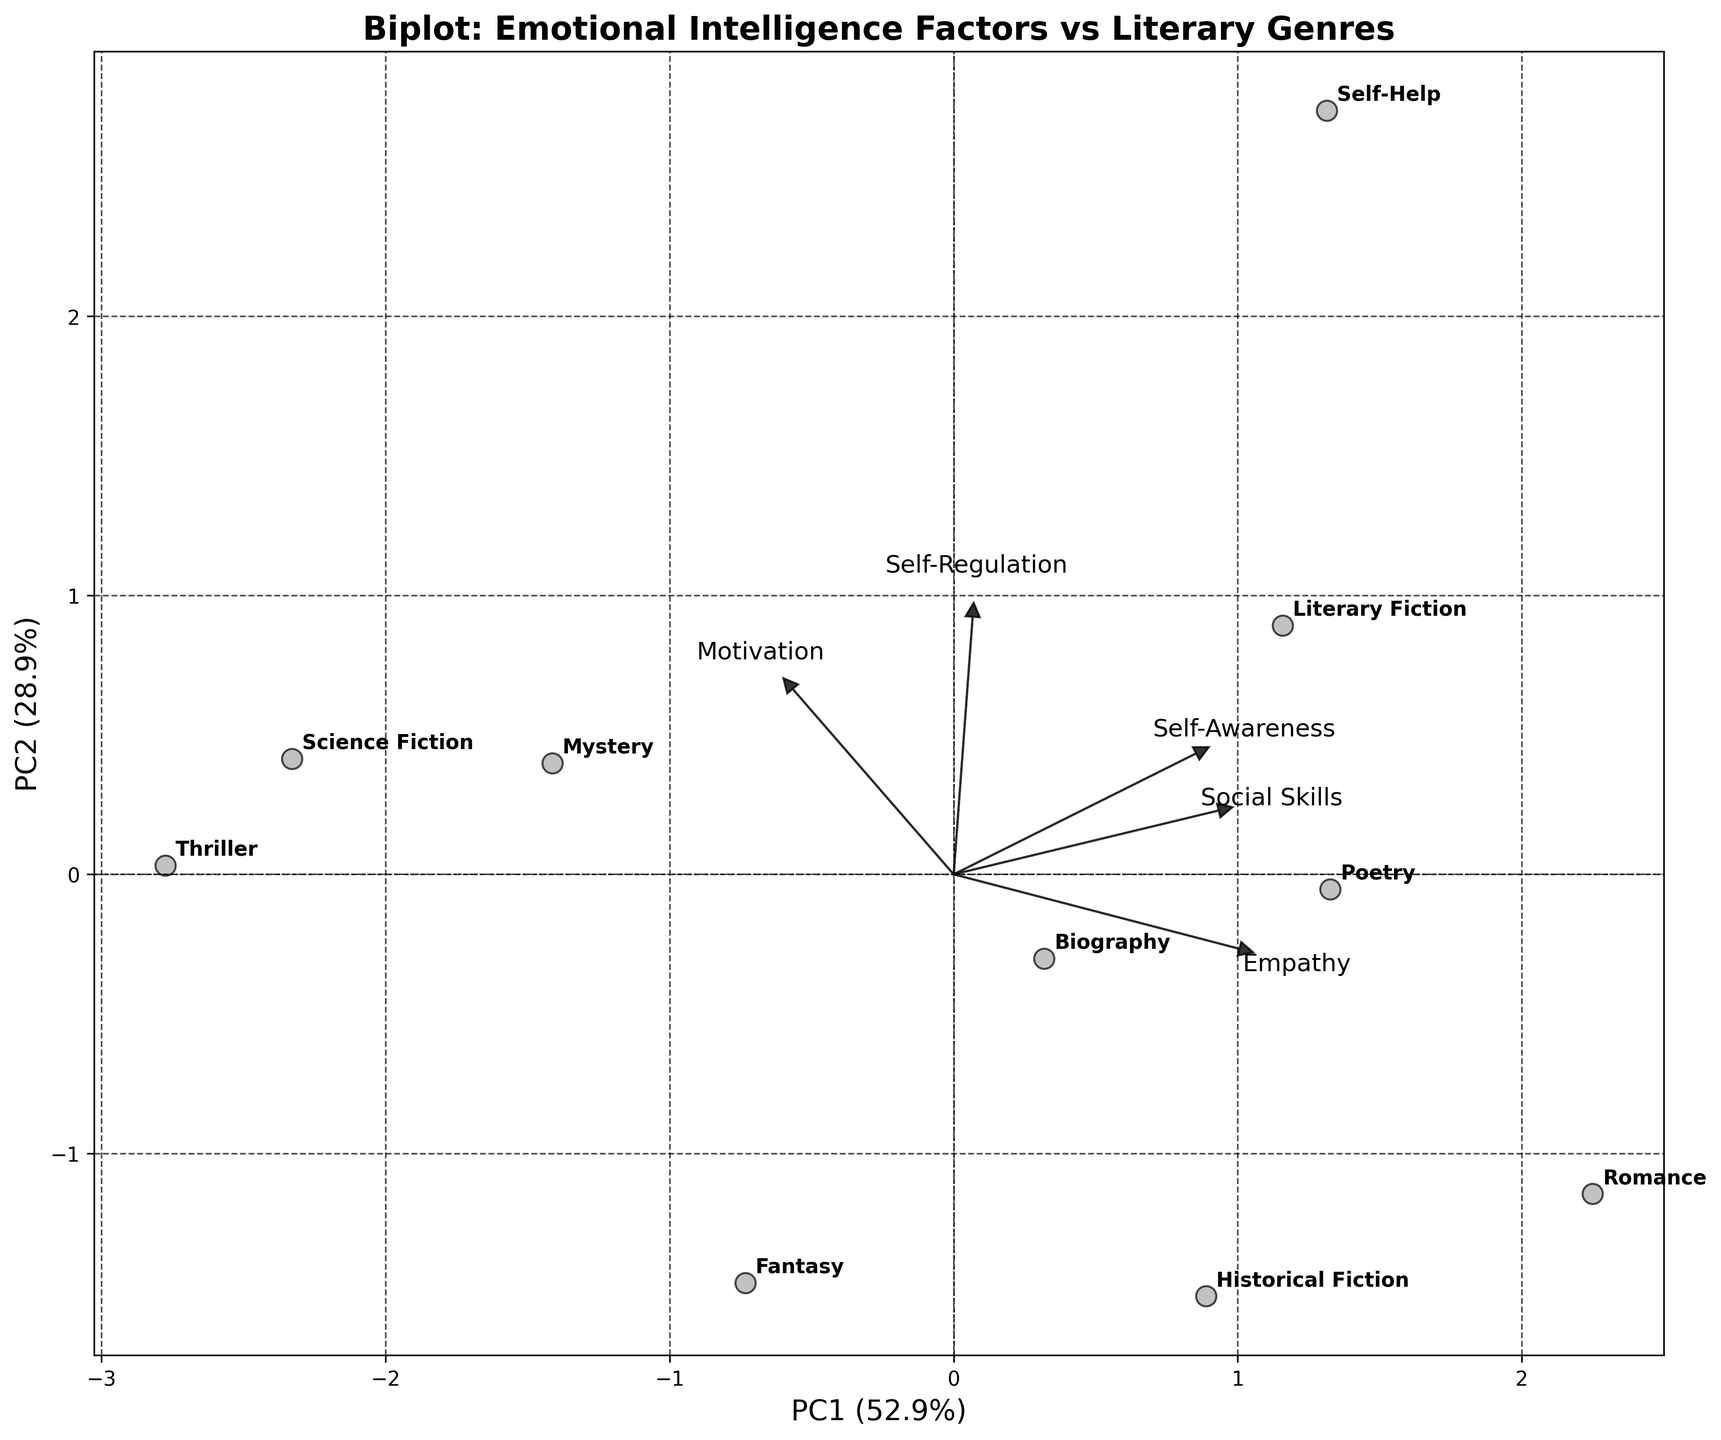What is the title of the plot? The title is located at the top of the plot and provides an overview of what the plot represents. The title in this plot is "Biplot: Emotional Intelligence Factors vs Literary Genres".
Answer: Biplot: Emotional Intelligence Factors vs Literary Genres How many literary genres are represented in this plot? Each data point in the plot is labeled with a literary genre. By visually counting the labels, you can determine the number of genres. There are 10 genres in the plot: Romance, Mystery, Science Fiction, Literary Fiction, Self-Help, Biography, Historical Fiction, Poetry, Thriller, and Fantasy.
Answer: 10 Which genre is closest to the origin of the plot? The origin is located at (0, 0). By examining the scatter plot, we look for the data point nearest to the origin. The genre closest to the origin is "Science Fiction".
Answer: Science Fiction What are the principal components' percentage explained variances for PC1 and PC2? Look at the labels of the x-axis and y-axis to find the explained variances. PC1 and PC2 are labeled with the percentages of variance they explain: PC1 explains 44.0% and PC2 explains 24.5%.
Answer: PC1: 44.0%, PC2: 24.5% Which Emotional Intelligence factor is most strongly aligned with PC1? The loadings indicate the influence of each feature on the principal components. The arrows representing the loadings point in the direction of the highest influence. The "Self-Awareness" arrow points furthest along the PC1 axis.
Answer: Self-Awareness Which genres are most strongly associated with the "Self-Regulation" factor? Find the "Self-Regulation" arrow and see which genres lie in its direction. "Self-Help" and "Thriller" are plotted in the direction of the "Self-Regulation" factor.
Answer: Self-Help and Thriller What is the approximate direction of the "Empathy" factor's loading? Observe the direction of the "Empathy" arrow. It points towards the top-left quadrant of the plot, indicating that high values of Empathy move in that direction.
Answer: Top-left quadrant Between "Romance" and "Mystery", which genre has a higher association with "Motivation"? Look at the plot positions relative to the "Motivation" arrow. "Science Fiction" and "Thriller" seem closer to the direction of "Motivation", so of the two options, "Mystery" is closer.
Answer: Mystery Which factor does "Poetry" align most closely with? Identify the "Poetry" data point and examine which arrow it aligns with the most. "Poetry" is closest to the arrows for "Self-Awareness" and "Empathy".
Answer: Self-Awareness and Empathy 